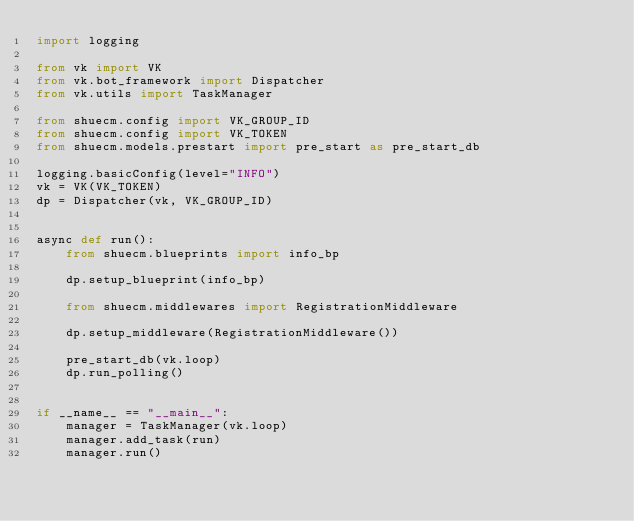Convert code to text. <code><loc_0><loc_0><loc_500><loc_500><_Python_>import logging

from vk import VK
from vk.bot_framework import Dispatcher
from vk.utils import TaskManager

from shuecm.config import VK_GROUP_ID
from shuecm.config import VK_TOKEN
from shuecm.models.prestart import pre_start as pre_start_db

logging.basicConfig(level="INFO")
vk = VK(VK_TOKEN)
dp = Dispatcher(vk, VK_GROUP_ID)


async def run():
    from shuecm.blueprints import info_bp

    dp.setup_blueprint(info_bp)

    from shuecm.middlewares import RegistrationMiddleware

    dp.setup_middleware(RegistrationMiddleware())

    pre_start_db(vk.loop)
    dp.run_polling()


if __name__ == "__main__":
    manager = TaskManager(vk.loop)
    manager.add_task(run)
    manager.run()
</code> 